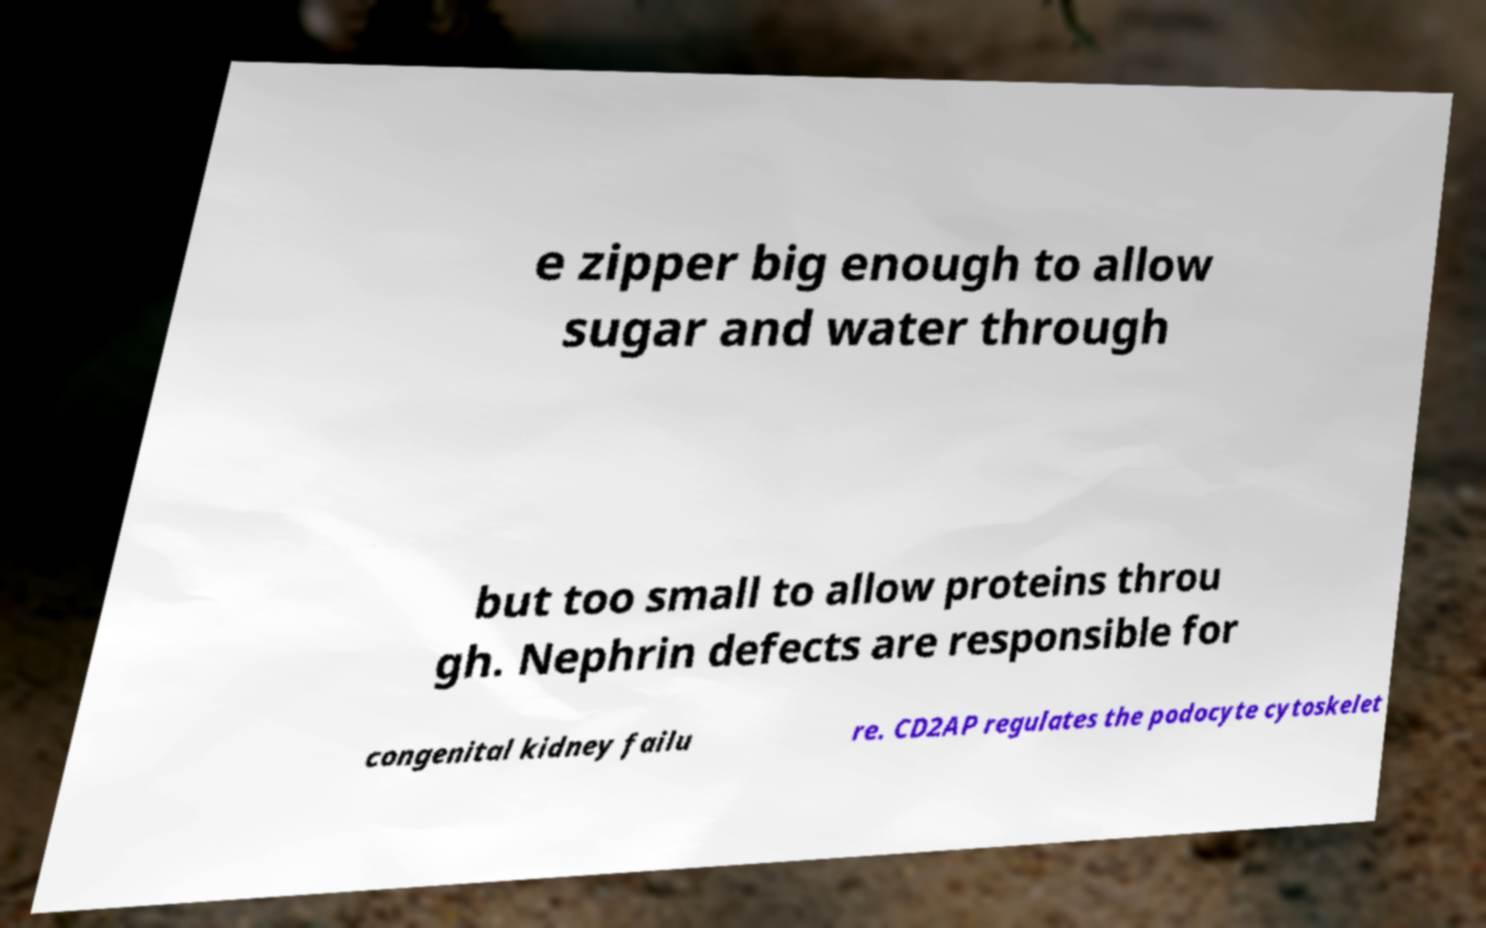Please read and relay the text visible in this image. What does it say? e zipper big enough to allow sugar and water through but too small to allow proteins throu gh. Nephrin defects are responsible for congenital kidney failu re. CD2AP regulates the podocyte cytoskelet 